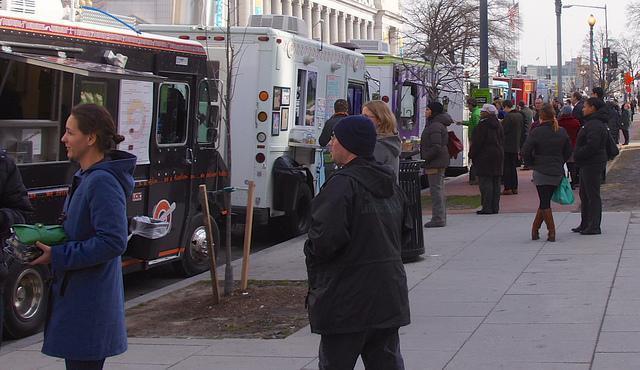How many people are visible?
Give a very brief answer. 6. How many trucks can be seen?
Give a very brief answer. 3. 